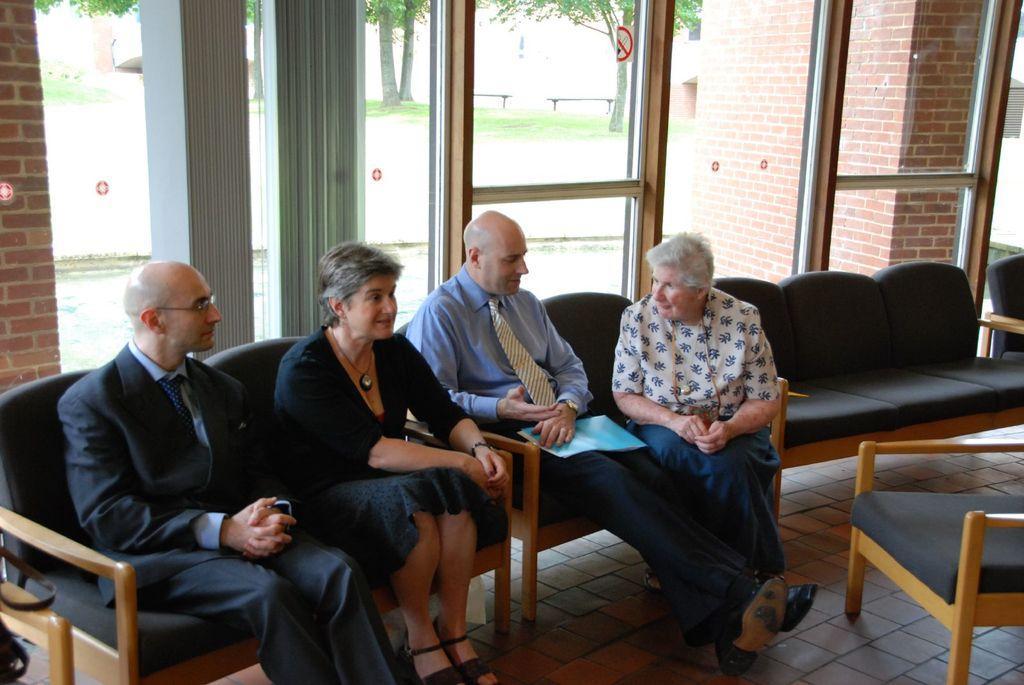Please provide a concise description of this image. In this picture, we see four people are sitting on the sofa chairs. On the right side, we see a chair. Behind them, we see the glass windows and a door from which we can see the benches, trees and grass. On the right side, we see a wall which is made up of bricks. Behind that, we see a white wall. On the left side, we see a wall. 